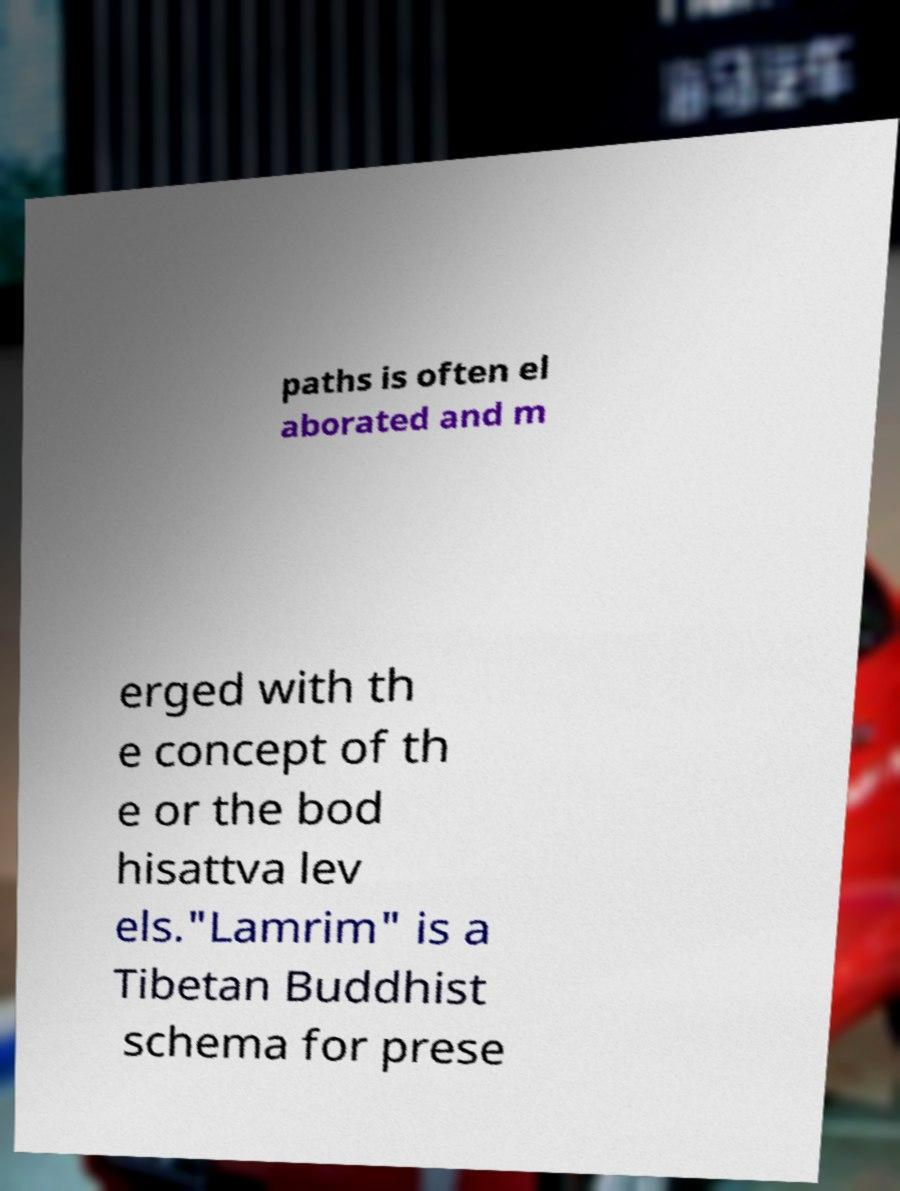For documentation purposes, I need the text within this image transcribed. Could you provide that? paths is often el aborated and m erged with th e concept of th e or the bod hisattva lev els."Lamrim" is a Tibetan Buddhist schema for prese 